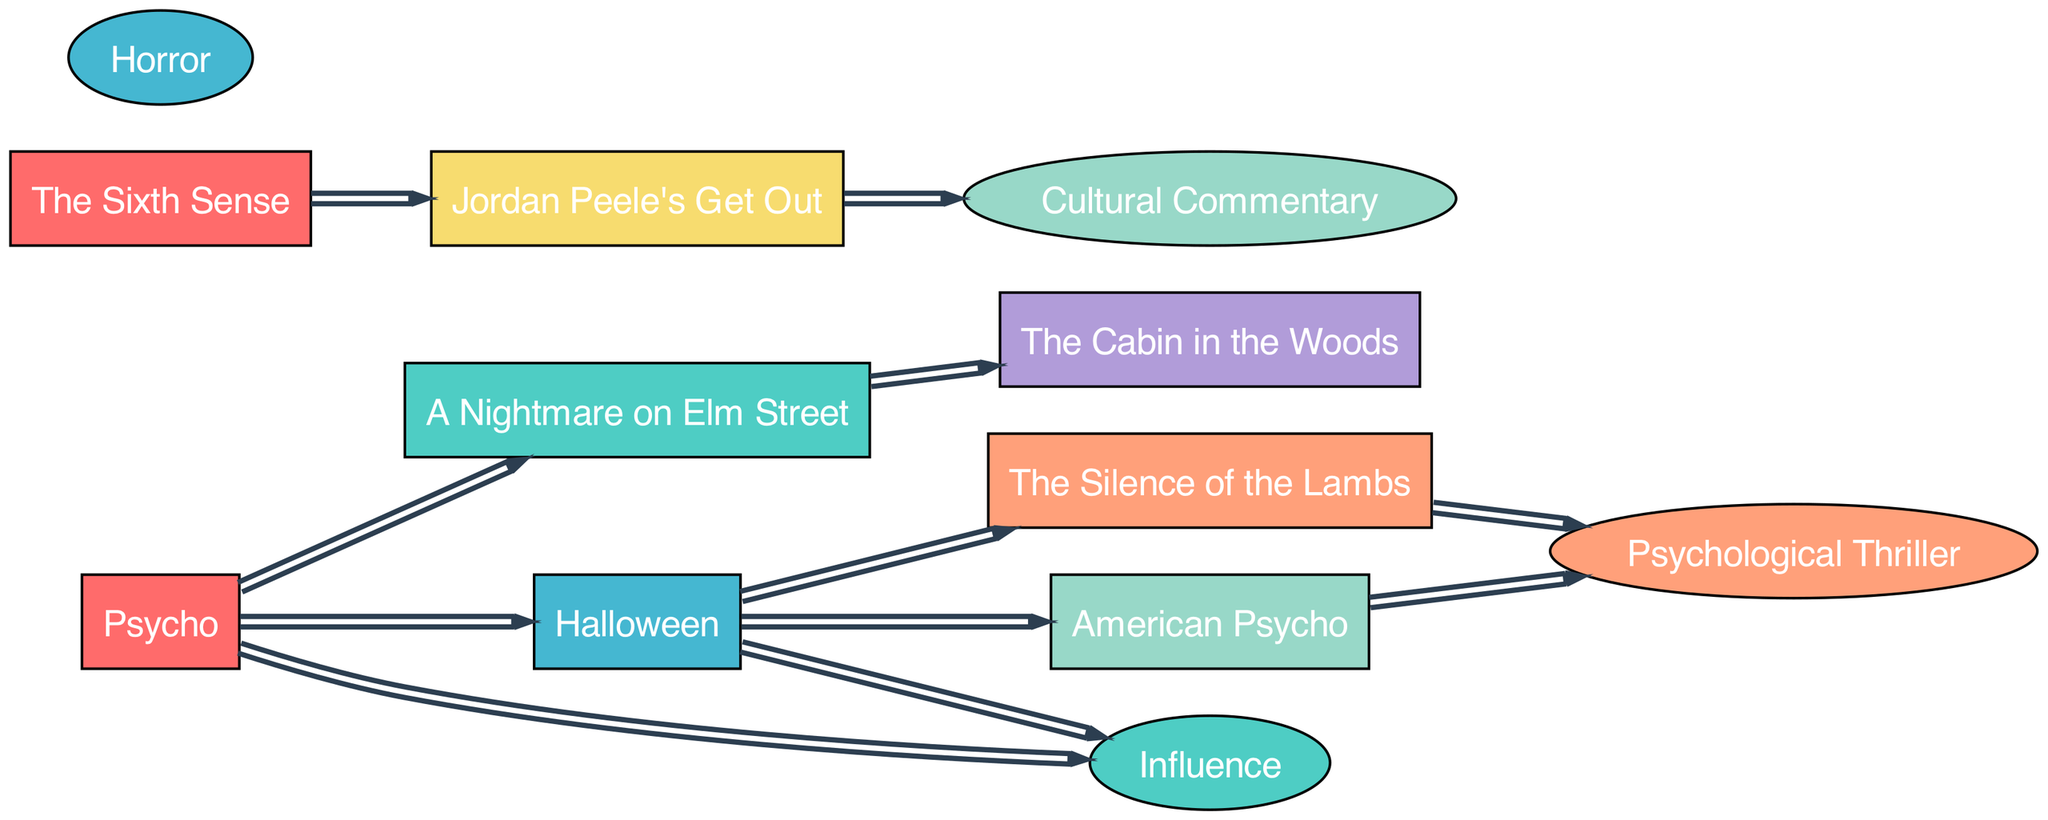What is the total number of films depicted in the diagram? The diagram contains a list of nodes categorized as films. By counting all the nodes labeled as 'Film', we see there are eight distinct films.
Answer: 8 Which film has a direct influence on American Psycho? American Psycho is directly influenced by Halloween, as indicated by the link from Halloween to American Psycho.
Answer: Halloween How many films directly influence Halloween? The diagram shows that two films, Psycho and A Nightmare on Elm Street, have direct influence connections leading to Halloween.
Answer: 2 What theme is represented by Jordan Peele's Get Out? The diagram specifies that Jordan Peele's Get Out connects to the node 'Cultural Commentary', indicating its representation of this theme.
Answer: Cultural Commentary Which film is the primary influence connecting to The Silence of the Lambs? The link indicates that Halloween serves as the primary influence, as it directly connects to The Silence of the Lambs.
Answer: Halloween Which genre is represented by The Silence of the Lambs? According to the diagram, there is a direct link from The Silence of the Lambs to the genre represented as 'Psychological Thriller'.
Answer: Psychological Thriller How many total influence connections are visible in the diagram? To determine the total influence connections, we can count all the links shown in the diagram. There are eleven links indicating direct influences.
Answer: 11 Which film serves as an influence for both The Cabin in the Woods and A Nightmare on Elm Street? A Nightmare on Elm Street is influenced by Psycho and, in turn, it influences The Cabin in the Woods, connecting these two films indirectly through influence.
Answer: Psycho Which film connects to the theme of Psychological Thriller? The films directly linked to the theme of 'Psychological Thriller' are The Silence of the Lambs and American Psycho, showing their relationship to this genre.
Answer: The Silence of the Lambs and American Psycho 